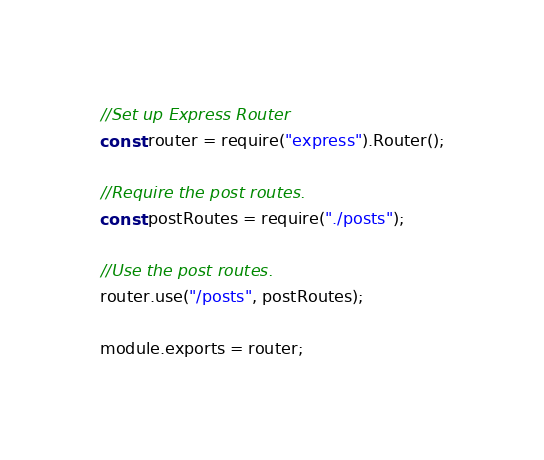Convert code to text. <code><loc_0><loc_0><loc_500><loc_500><_JavaScript_>//Set up Express Router
const router = require("express").Router();

//Require the post routes.
const postRoutes = require("./posts");

//Use the post routes.
router.use("/posts", postRoutes);

module.exports = router;</code> 